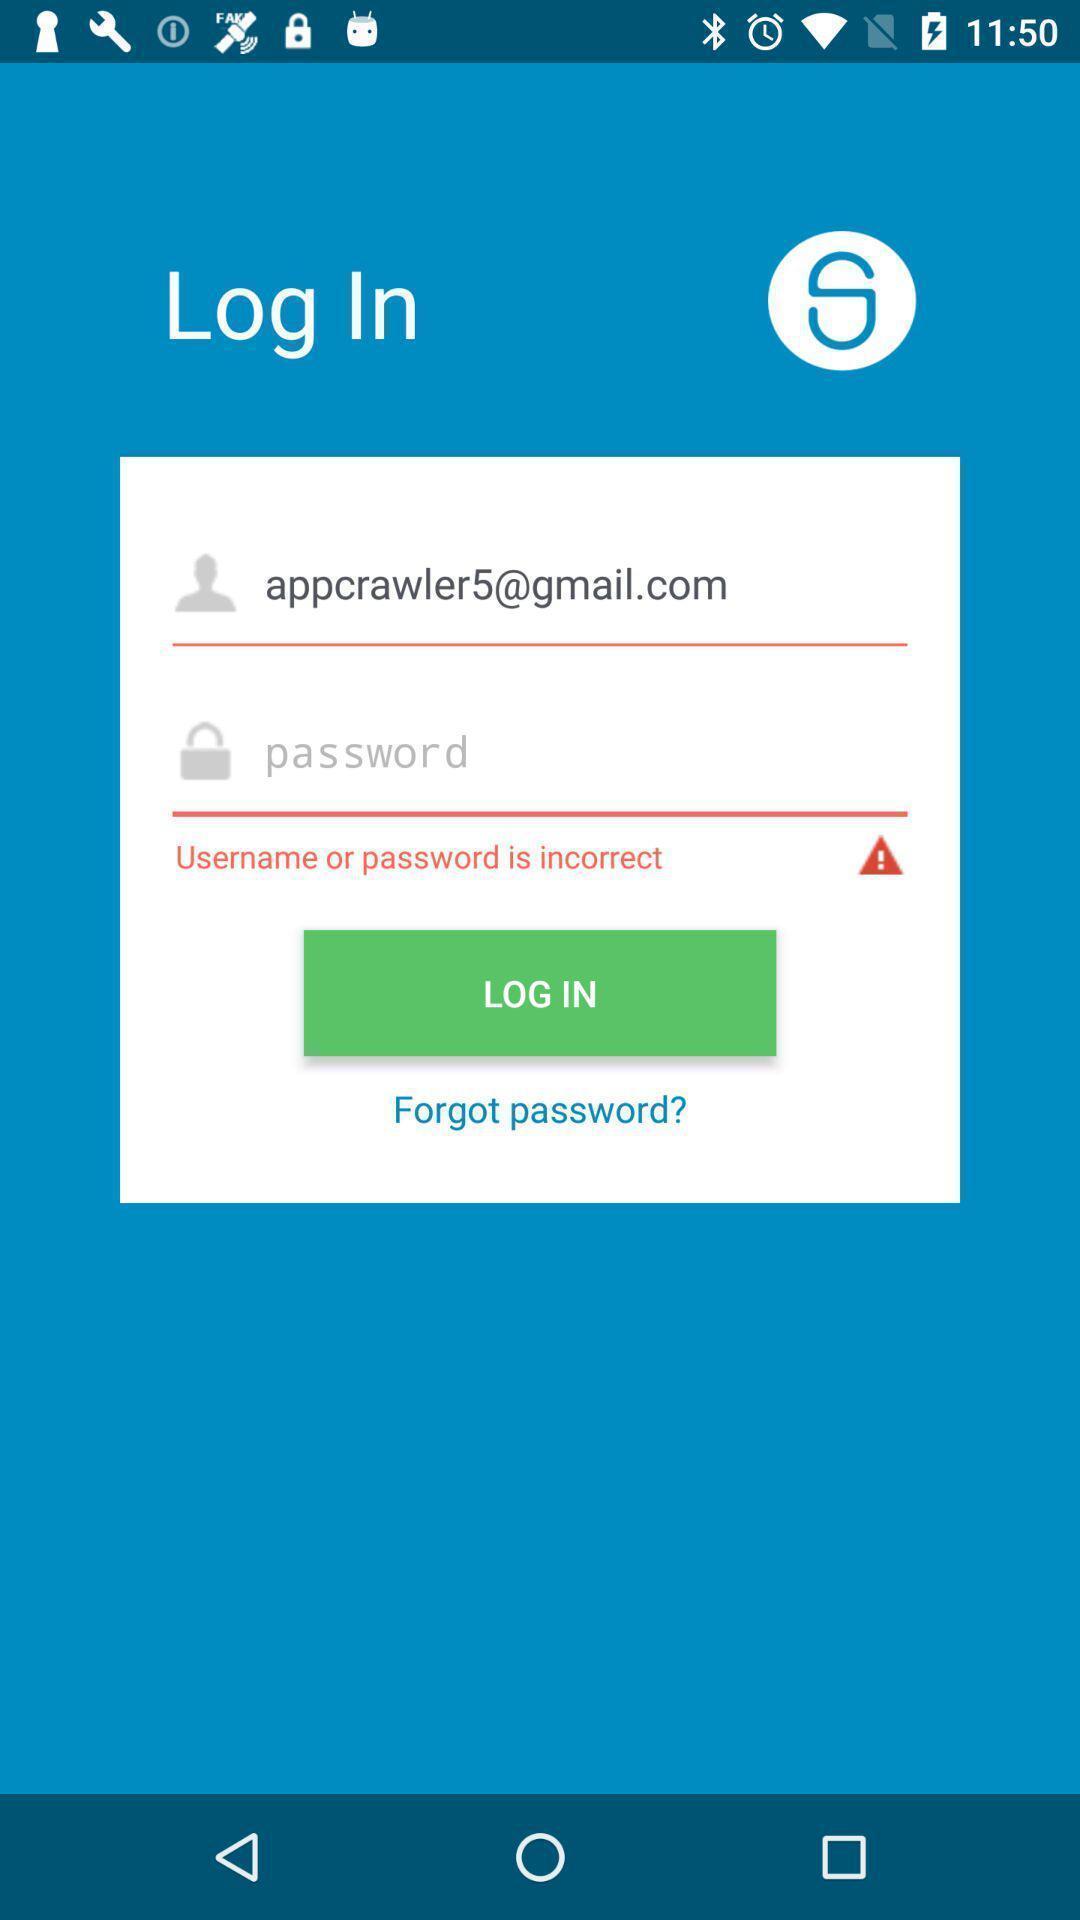Tell me about the visual elements in this screen capture. Login page with incorrect password. 